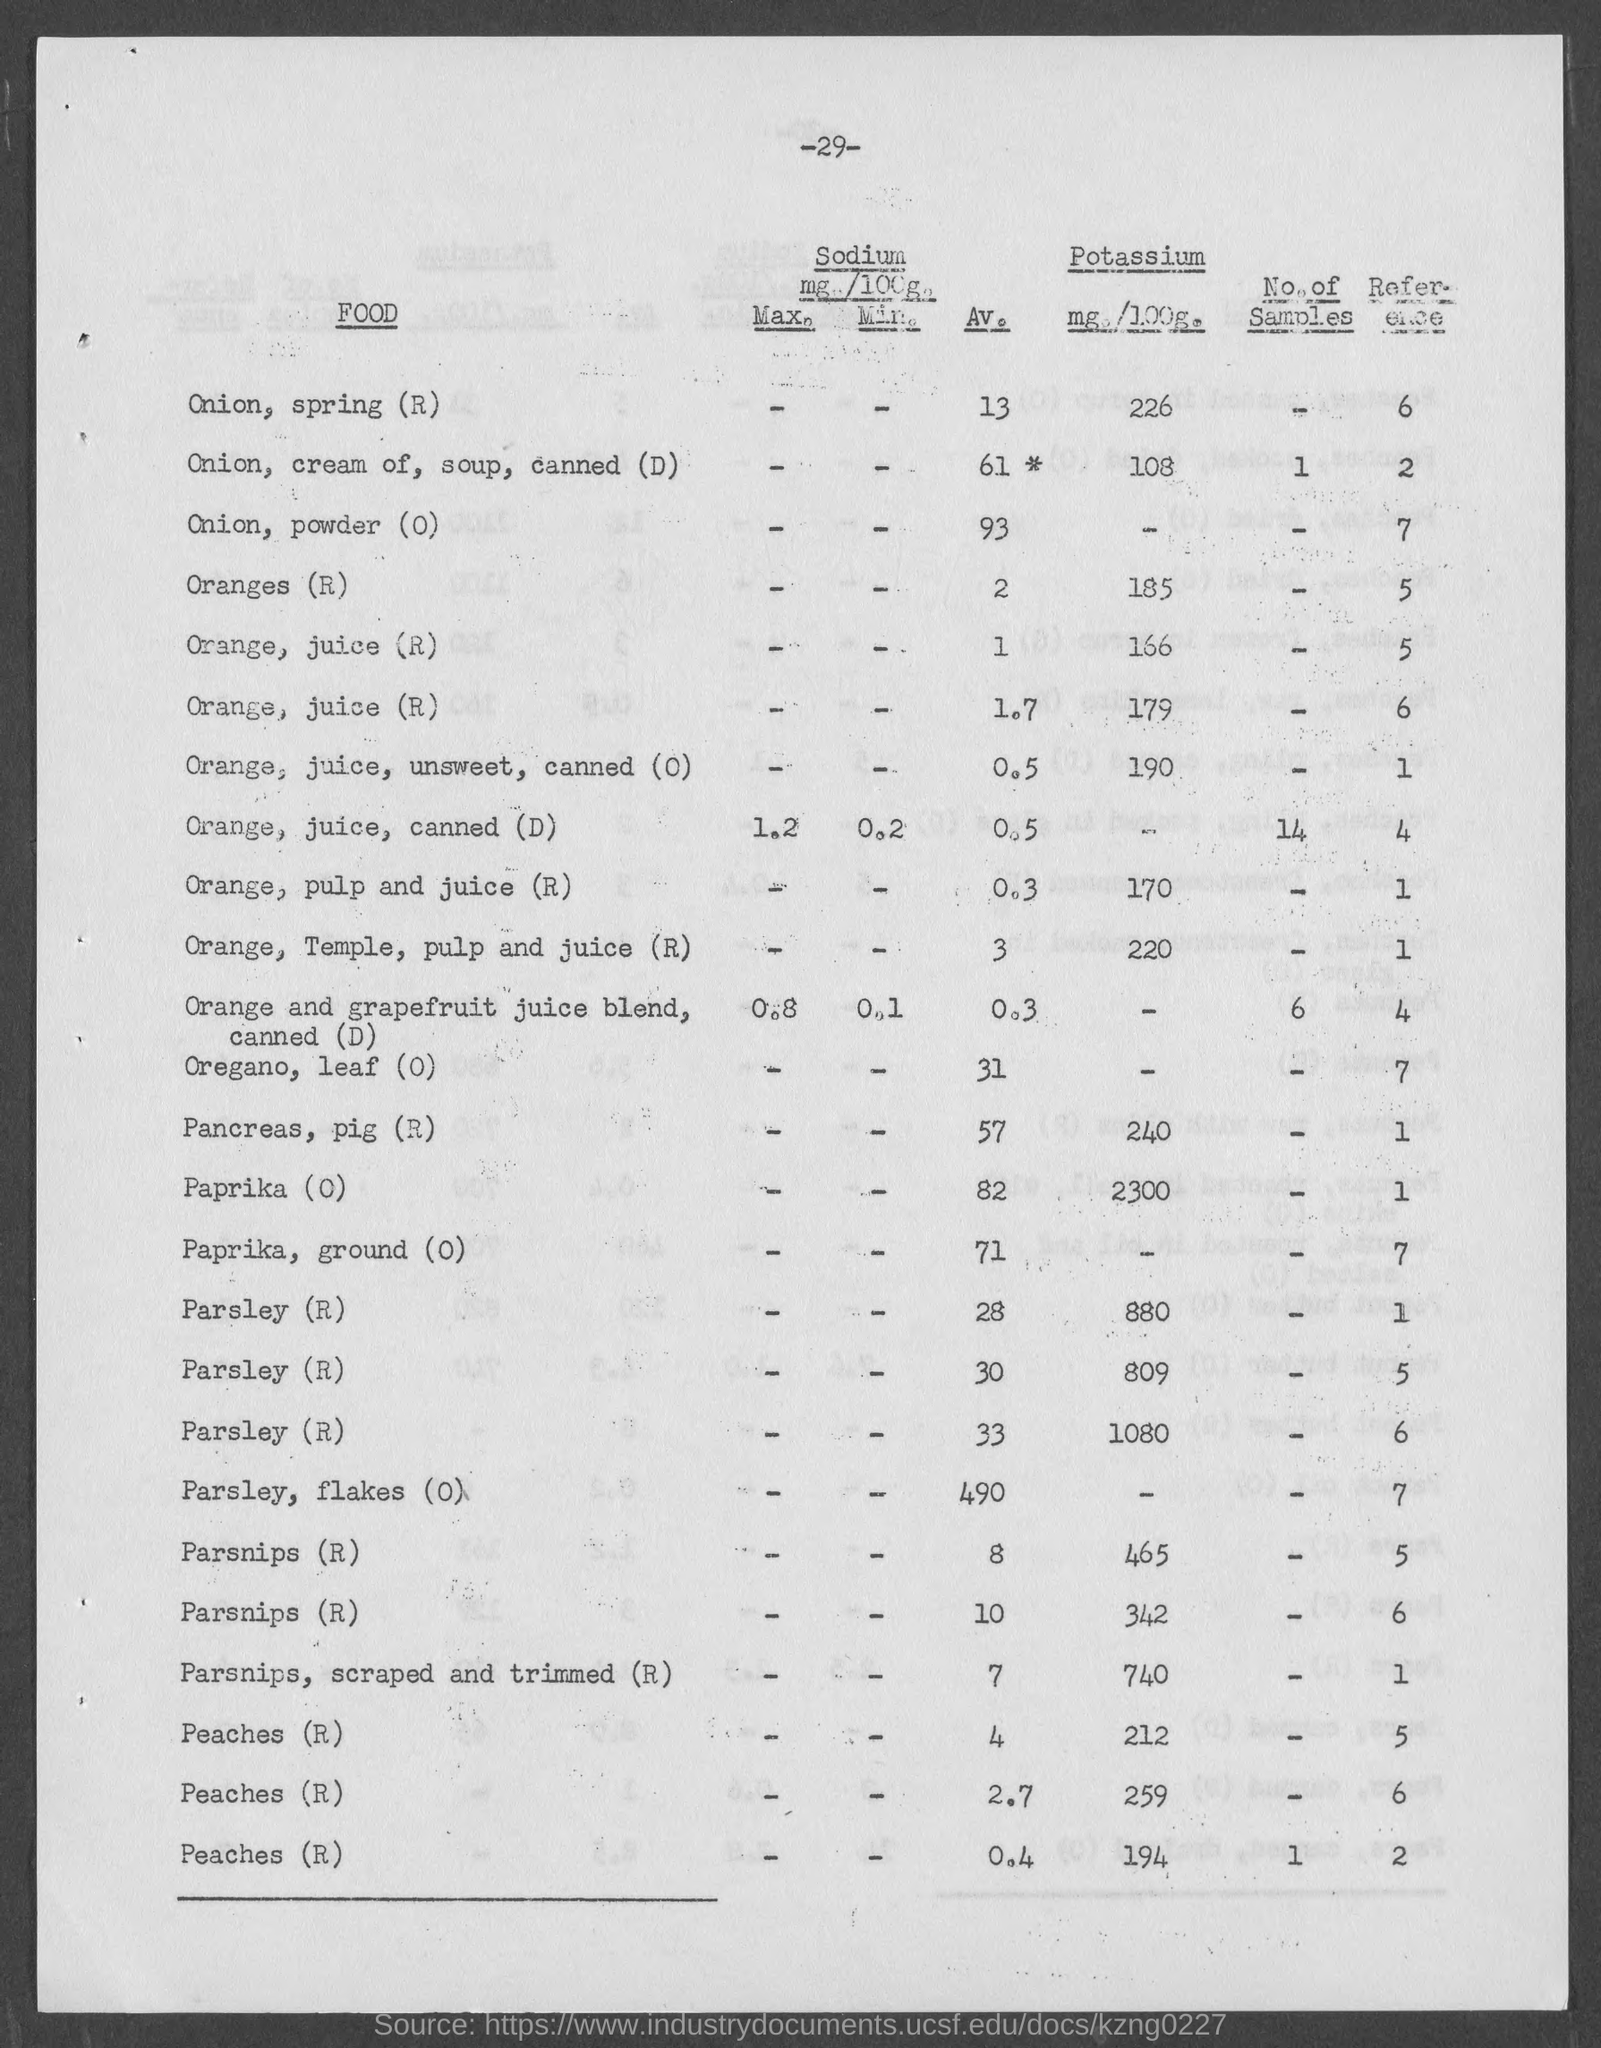What is the av. value of sodium present in onion, spring(r) as mentioned in the given page ?
Provide a short and direct response. 13. What is the av. value of onion, powder(o) as mentioned in the given page ?
Offer a very short reply. 93. What is the value of potassium present in onion,spring(r) as mentioned in the given page ?
Your response must be concise. 226. What is the max. value of sodium present in orange, juice, canned (d) as mentioned in the given page ?
Provide a succinct answer. 1.2. What is the av. value of pancreas, pig(r)  as mentioned in the given page ?
Offer a very short reply. 57. What is the value of potassium present in oranges(r) as mentioned in the given page ?
Make the answer very short. 185. What  is the value of potassium present in paprika(o) as mentioned in the given form ?
Your answer should be compact. 2300. What is the av. value of paprika(o) as mentioned in the given page ?
Give a very brief answer. 82. 